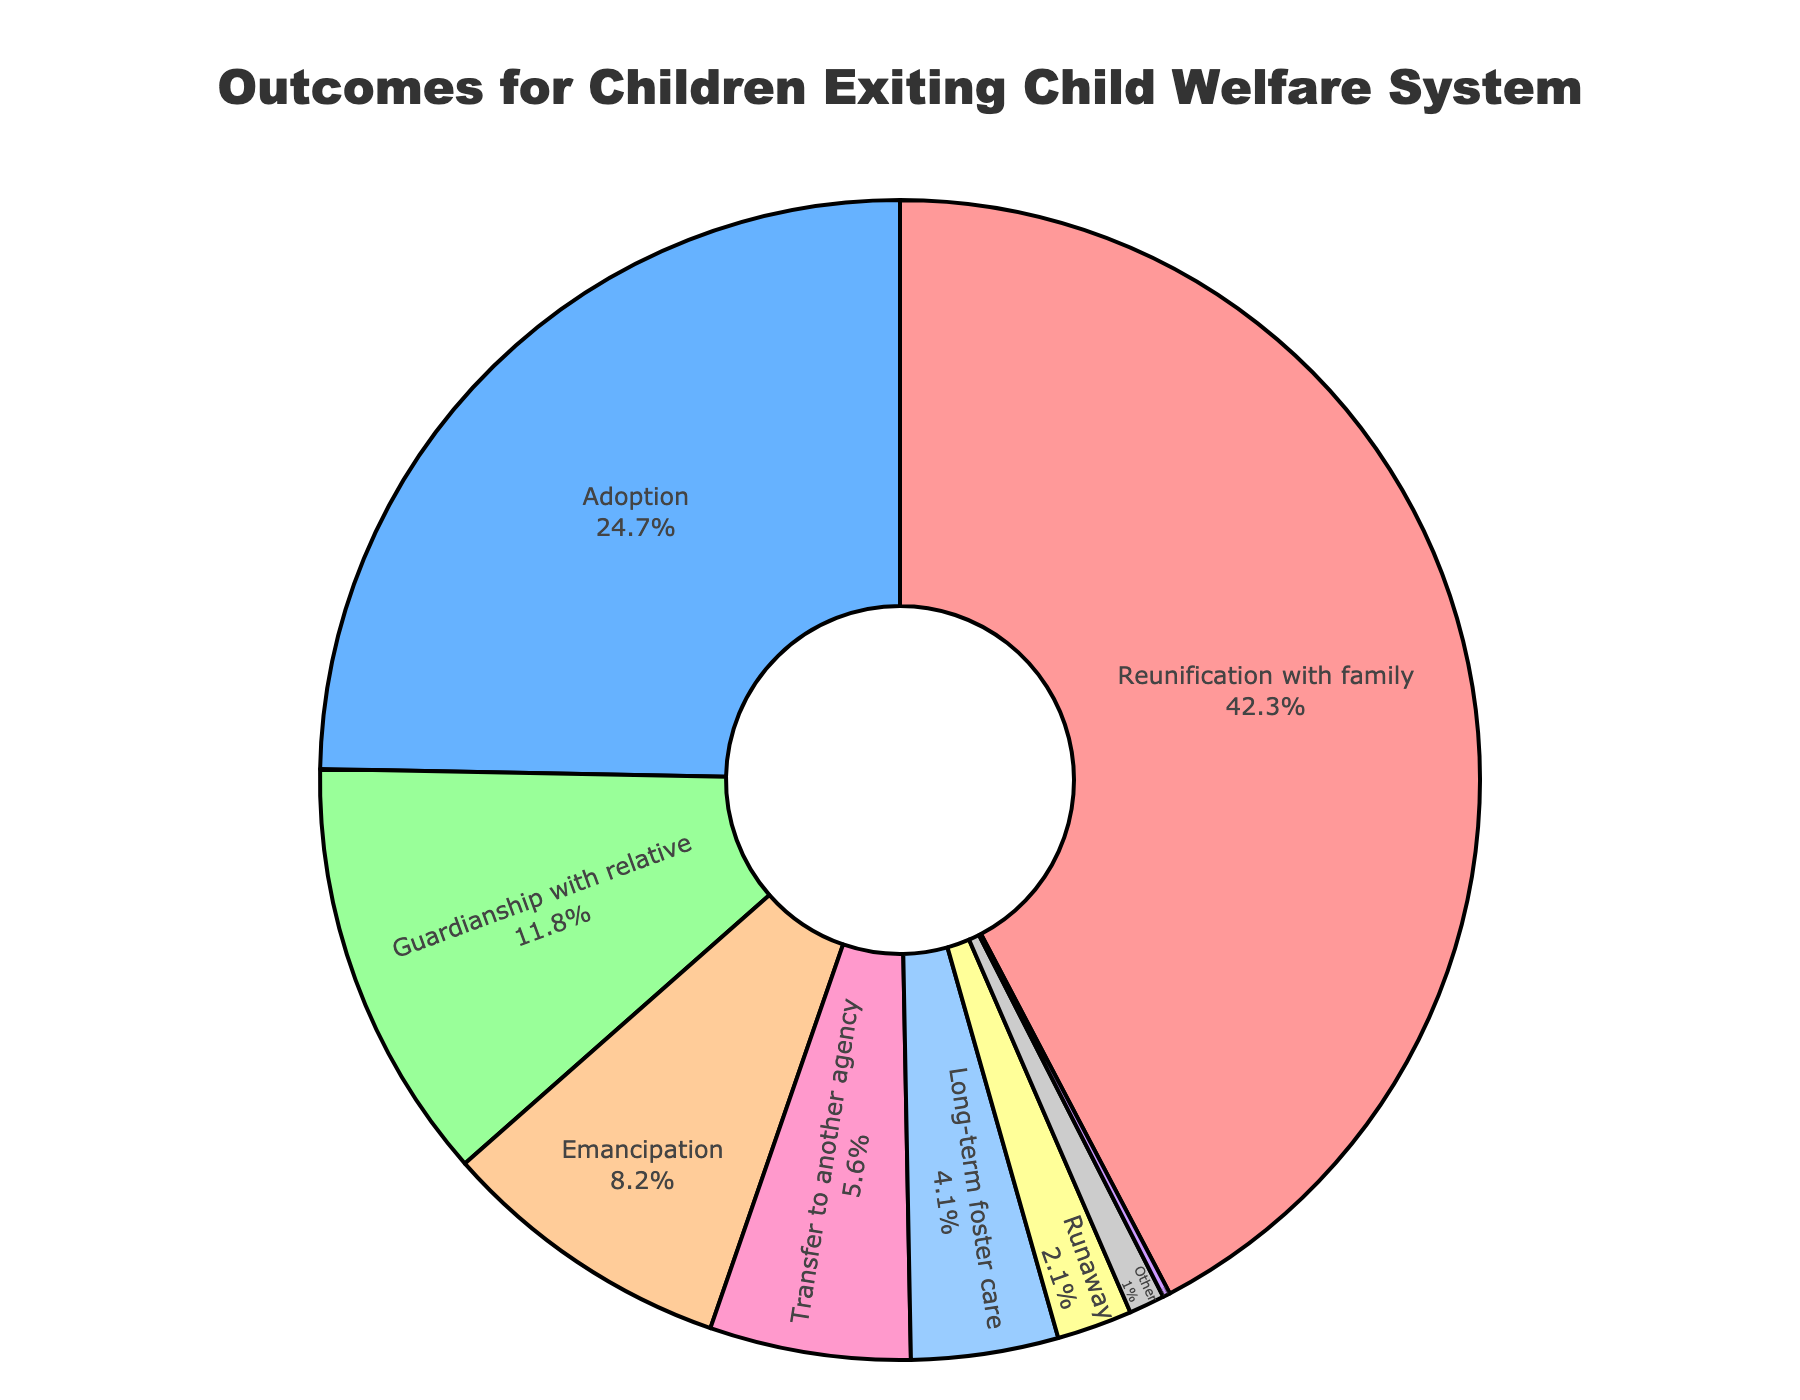What is the percentage of children who were reunited with their families? Locate the 'Reunification with family' segment in the pie chart and note the percentage value next to it.
Answer: 42.3% Which outcome has the second highest percentage? Identify which segment comes after the largest one in occupying the most space within the pie chart. Check the label and percentage associated with it.
Answer: Adoption How much greater is the percentage of children reunited with their families compared to those who were adopted? Locate the 'Reunification with family' and 'Adoption' segments. Subtract the percentage of 'Adoption' from 'Reunification with family' (42.3% - 24.7%).
Answer: 17.6% What is the combined percentage of children who were emancipated, transferred to another agency, or ran away? Add the percentages for 'Emancipation', 'Transfer to another agency', and 'Runaway' (8.2% + 5.6% + 2.1%).
Answer: 15.9% Are there more children placed in 'Guardianship with a relative' or those in 'Long-term foster care'? Compare the percentages for 'Guardianship with relative' (11.8%) and 'Long-term foster care' (4.1%).
Answer: Guardianship with relative How does the percentage of 'Emancipation' compare to 'Guardianship with a relative'? Compare the percentages for 'Emancipation' and 'Guardianship with relative' directly (8.2% vs 11.8%).
Answer: Less How many percentage points more is 'Transfer to another agency' than 'Runaway'? Subtract the percentage of 'Runaway' from 'Transfer to another agency' (5.6% - 2.1%).
Answer: 3.5% What color represents the 'Adoption' outcome? Identify the segment labeled 'Adoption' and observe its color in the pie chart.
Answer: Blue Which outcome is represented by the smallest slice, and what is its percentage? Find the smallest segment in the pie chart and note its label and percentage value.
Answer: Death, 0.2% What percentage of children are accounted for by 'Other' outcomes? Locate the 'Other' segment and note the percentage value associated with it.
Answer: 1.0% 